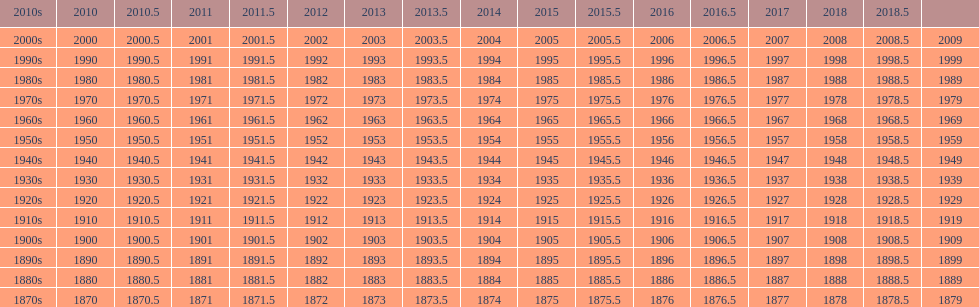Mathematically speaking, what is the difference between 2015 and 1912? 103. 